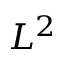<formula> <loc_0><loc_0><loc_500><loc_500>L ^ { 2 }</formula> 